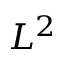<formula> <loc_0><loc_0><loc_500><loc_500>L ^ { 2 }</formula> 